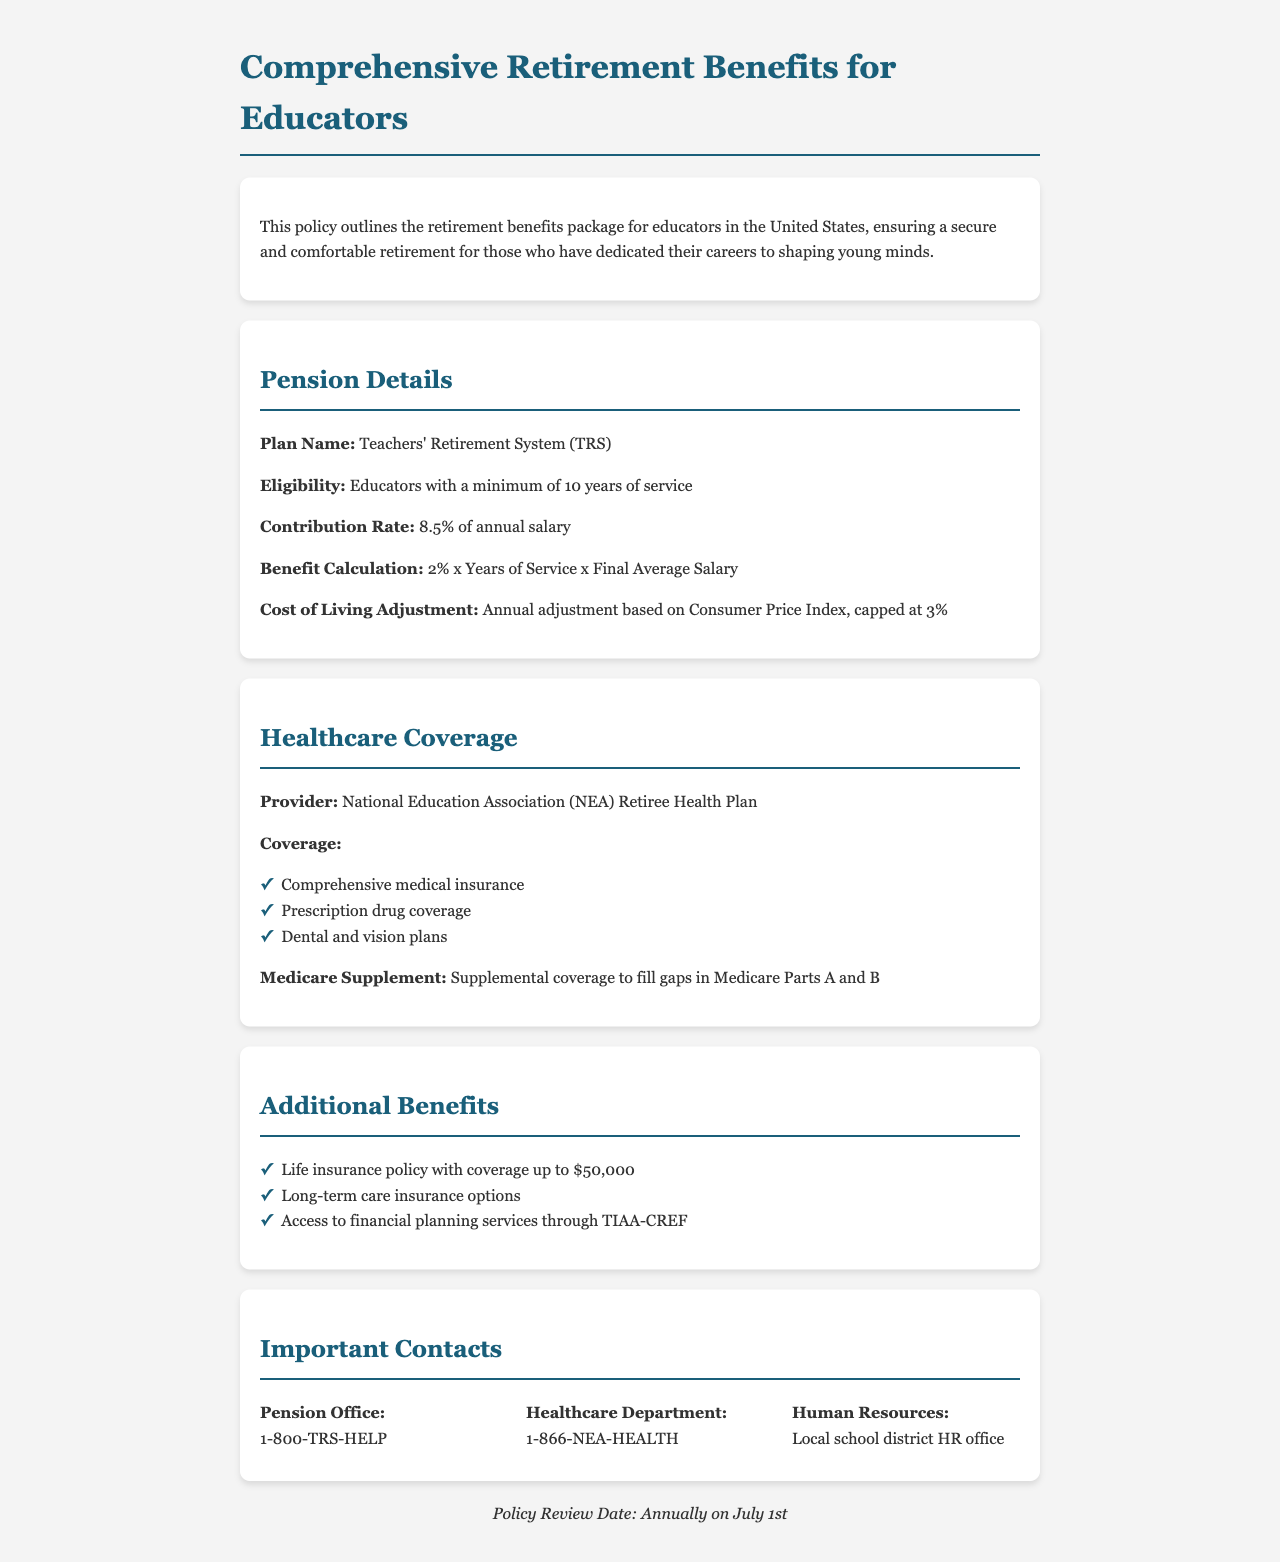What is the name of the pension plan? The document states that the pension plan is called the Teachers' Retirement System (TRS).
Answer: Teachers' Retirement System (TRS) What is the contribution rate for the pension? According to the document, the contribution rate is specified as 8.5% of annual salary.
Answer: 8.5% What is the cost of living adjustment cap? The document indicates that the cost of living adjustment is capped at 3%.
Answer: 3% What is included in the healthcare coverage? The document lists comprehensive medical insurance, prescription drug coverage, and dental and vision plans as included in healthcare coverage.
Answer: Comprehensive medical insurance, prescription drug coverage, dental and vision plans What is the life insurance policy coverage amount? The document mentions that the life insurance policy offers coverage up to $50,000.
Answer: $50,000 How many years of service are required for pension eligibility? The document specifies that a minimum of 10 years of service is required for pension eligibility.
Answer: 10 years What type of additional planning services are available? The additional benefits section states that access to financial planning services through TIAA-CREF is available.
Answer: TIAA-CREF What is the purpose of the Medicare Supplement? The document explains that the Medicare Supplement is for supplemental coverage to fill gaps in Medicare Parts A and B.
Answer: Fill gaps in Medicare Parts A and B When is the policy review date? The footer of the document indicates that the policy review date is annually on July 1st.
Answer: Annually on July 1st 